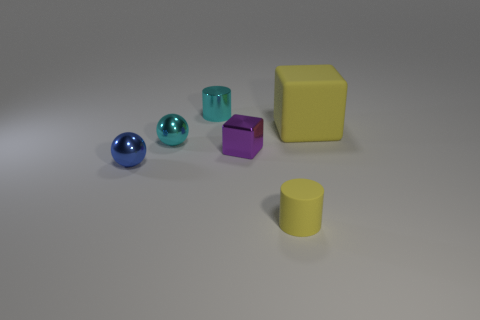Add 4 gray cylinders. How many objects exist? 10 Subtract 1 purple cubes. How many objects are left? 5 Subtract all cylinders. How many objects are left? 4 Subtract 1 spheres. How many spheres are left? 1 Subtract all yellow balls. Subtract all purple cylinders. How many balls are left? 2 Subtract all cyan blocks. How many purple balls are left? 0 Subtract all tiny gray cubes. Subtract all small blue metal spheres. How many objects are left? 5 Add 4 cyan metal cylinders. How many cyan metal cylinders are left? 5 Add 4 small things. How many small things exist? 9 